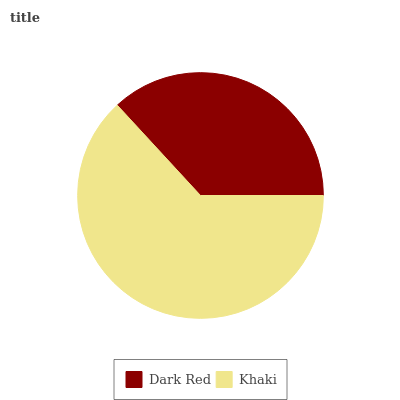Is Dark Red the minimum?
Answer yes or no. Yes. Is Khaki the maximum?
Answer yes or no. Yes. Is Khaki the minimum?
Answer yes or no. No. Is Khaki greater than Dark Red?
Answer yes or no. Yes. Is Dark Red less than Khaki?
Answer yes or no. Yes. Is Dark Red greater than Khaki?
Answer yes or no. No. Is Khaki less than Dark Red?
Answer yes or no. No. Is Khaki the high median?
Answer yes or no. Yes. Is Dark Red the low median?
Answer yes or no. Yes. Is Dark Red the high median?
Answer yes or no. No. Is Khaki the low median?
Answer yes or no. No. 